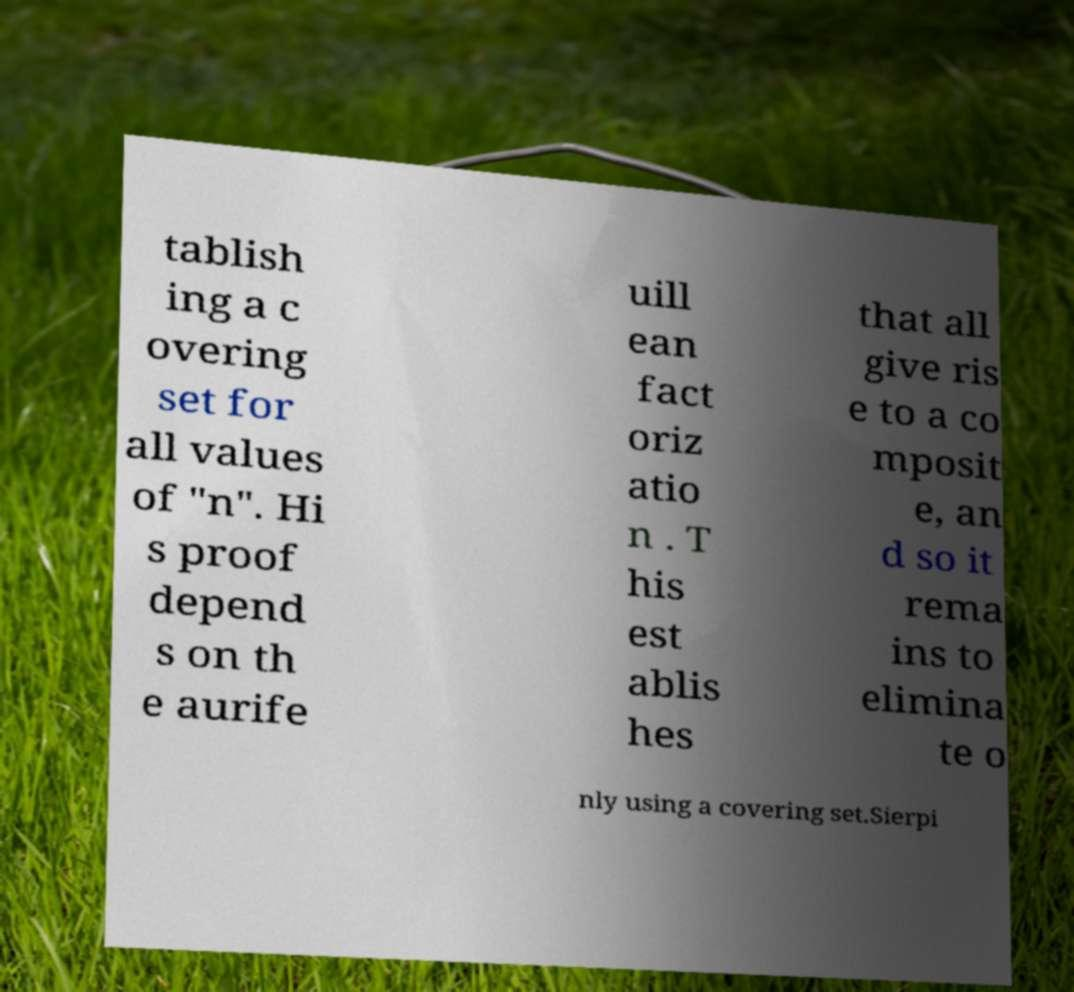For documentation purposes, I need the text within this image transcribed. Could you provide that? tablish ing a c overing set for all values of "n". Hi s proof depend s on th e aurife uill ean fact oriz atio n . T his est ablis hes that all give ris e to a co mposit e, an d so it rema ins to elimina te o nly using a covering set.Sierpi 